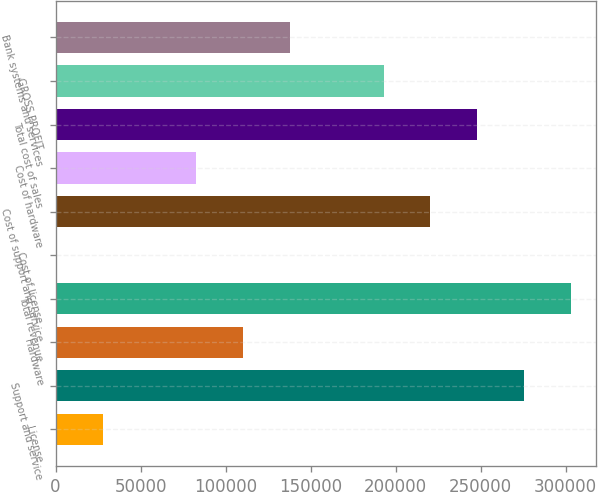Convert chart. <chart><loc_0><loc_0><loc_500><loc_500><bar_chart><fcel>License<fcel>Support and service<fcel>Hardware<fcel>Total revenue<fcel>Cost of license<fcel>Cost of support and service<fcel>Cost of hardware<fcel>Total cost of sales<fcel>GROSS PROFIT<fcel>Bank systems and services<nl><fcel>27867.9<fcel>275502<fcel>110413<fcel>303017<fcel>353<fcel>220472<fcel>82897.7<fcel>247987<fcel>192957<fcel>137928<nl></chart> 